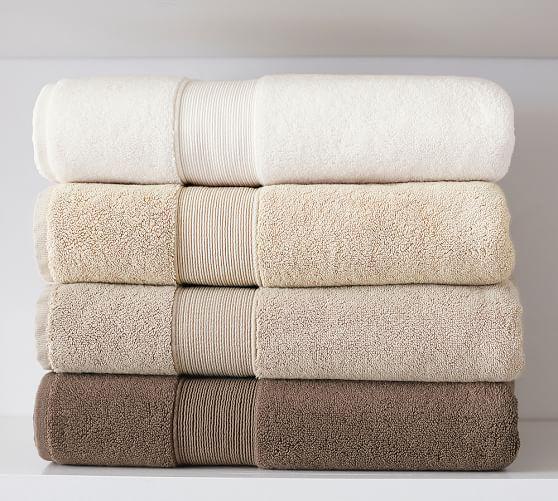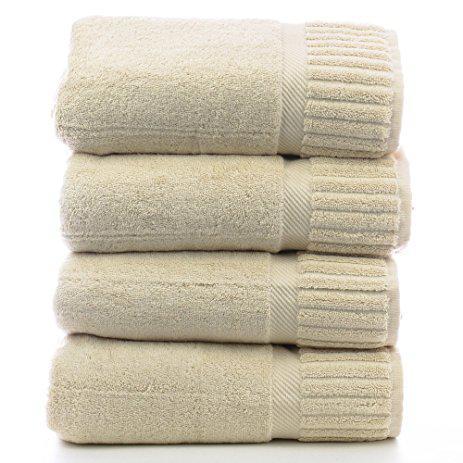The first image is the image on the left, the second image is the image on the right. Examine the images to the left and right. Is the description "There are exactly two towels." accurate? Answer yes or no. No. The first image is the image on the left, the second image is the image on the right. Assess this claim about the two images: "There is no less than six towels.". Correct or not? Answer yes or no. Yes. 